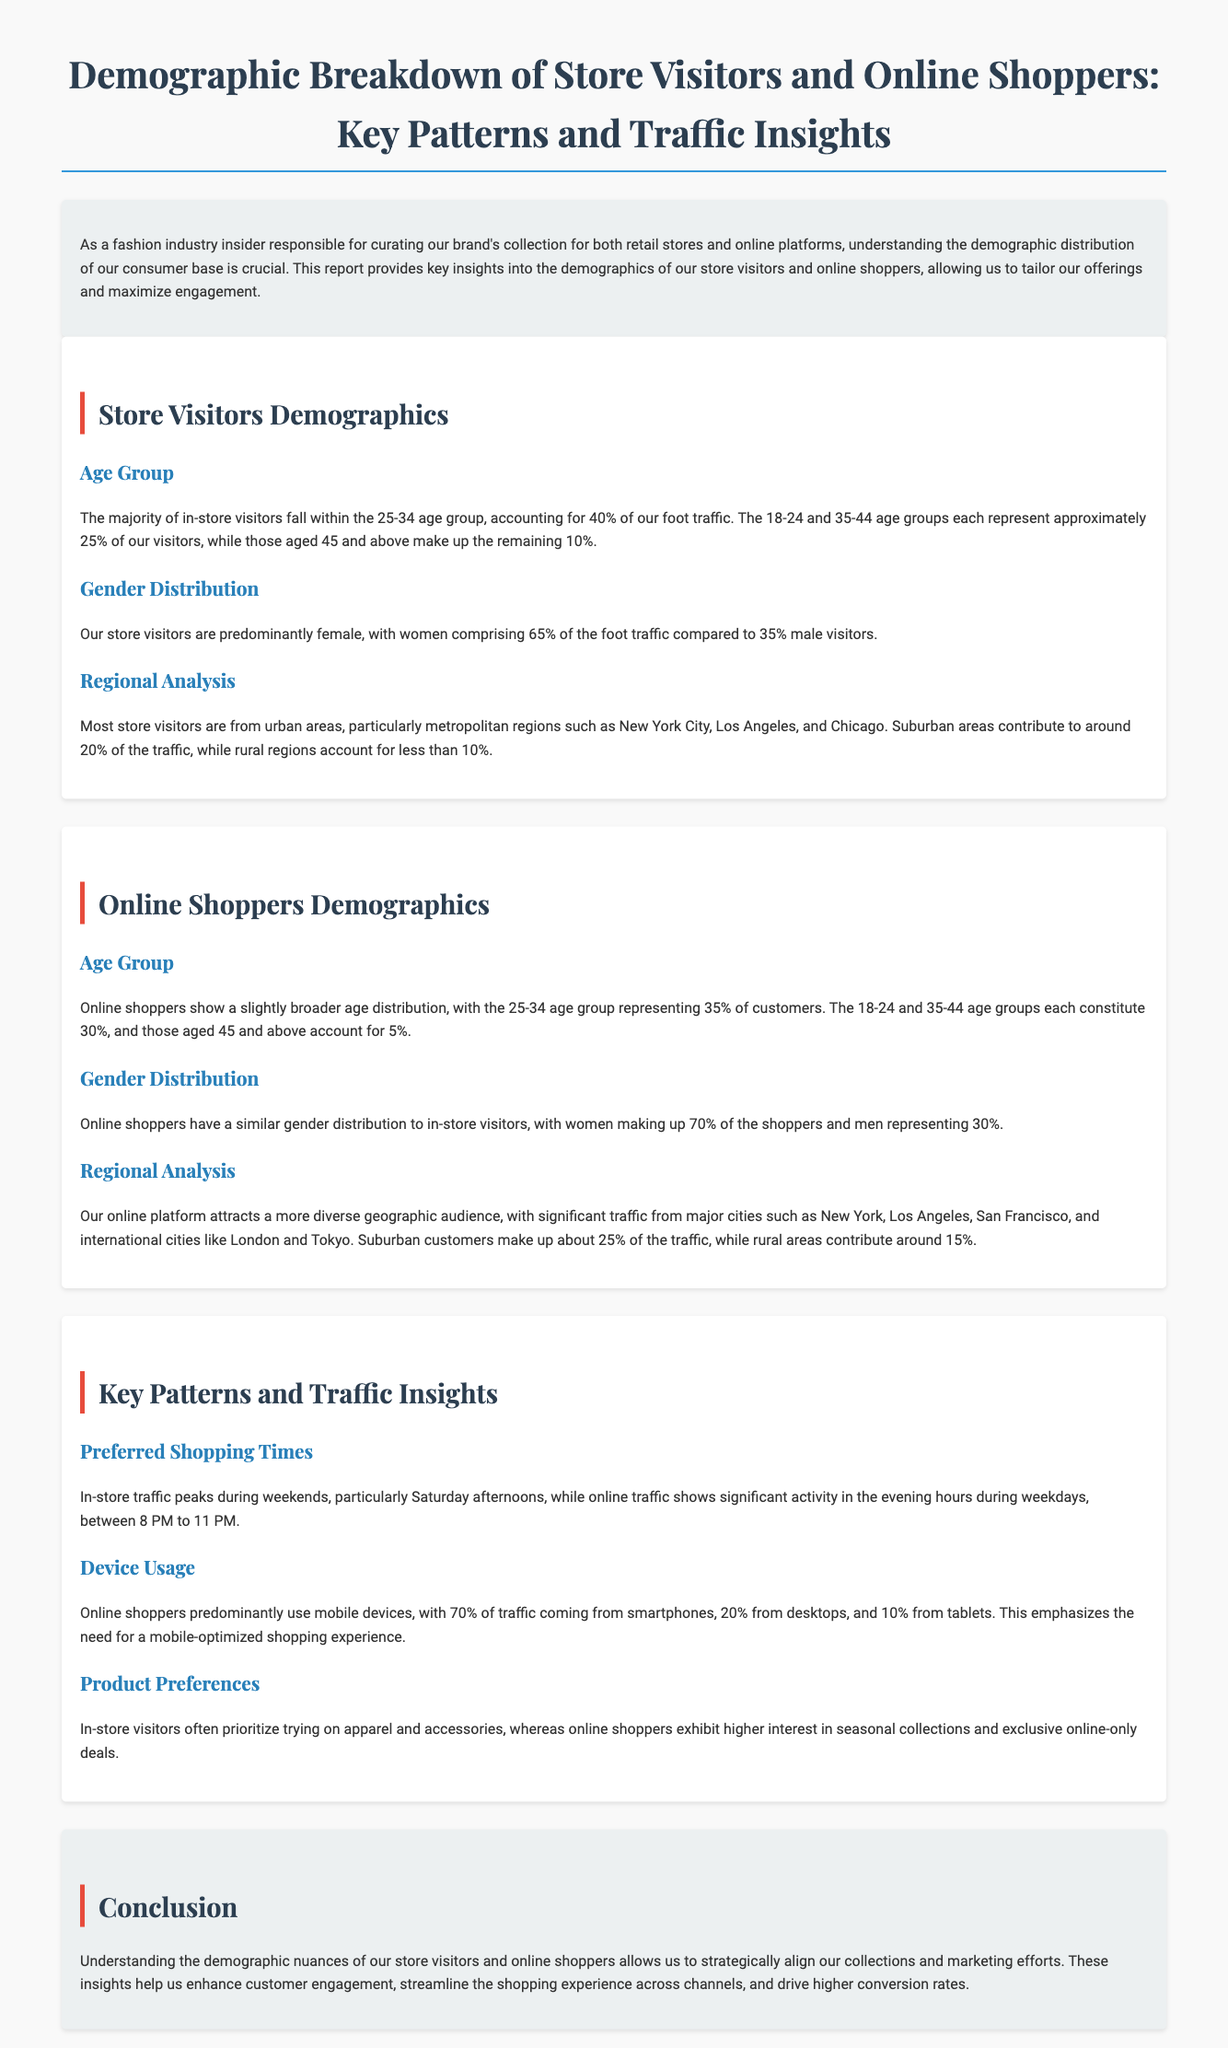What is the largest age group among in-store visitors? The largest age group among in-store visitors is the 25-34 age group, which accounts for 40% of foot traffic.
Answer: 25-34 age group What percentage of online shoppers are male? The document states that men represent 30% of online shoppers.
Answer: 30% Which gender comprises the majority of store visitors? Store visitors are predominantly female, with women comprising 65% of the foot traffic.
Answer: Female What is the age group with the least representation among online shoppers? The age group with the least representation among online shoppers is those aged 45 and above, accounting for 5%.
Answer: 45 and above During which days does in-store traffic peak? In-store traffic peaks during weekends, particularly Saturday afternoons.
Answer: Weekends What percentage of online traffic comes from mobile devices? Online shoppers predominantly use mobile devices, with 70% of traffic coming from smartphones.
Answer: 70% In which city do most store visitors originate? Most store visitors are from metropolitan regions such as New York City.
Answer: New York City What percentage of website traffic comes from suburban customers? Suburban customers make up about 25% of the online traffic.
Answer: 25% What time of day sees significant online shopping activity? Significant online shopping activity occurs in the evening hours during weekdays, between 8 PM to 11 PM.
Answer: 8 PM to 11 PM 